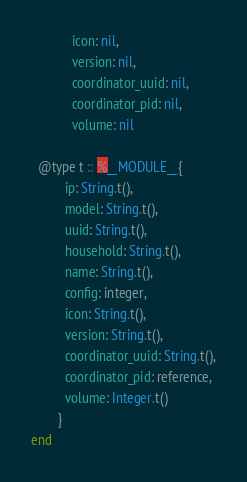Convert code to text. <code><loc_0><loc_0><loc_500><loc_500><_Elixir_>            icon: nil,
            version: nil,
            coordinator_uuid: nil,
            coordinator_pid: nil,
            volume: nil

  @type t :: %__MODULE__{
          ip: String.t(),
          model: String.t(),
          uuid: String.t(),
          household: String.t(),
          name: String.t(),
          config: integer,
          icon: String.t(),
          version: String.t(),
          coordinator_uuid: String.t(),
          coordinator_pid: reference,
          volume: Integer.t()
        }
end
</code> 